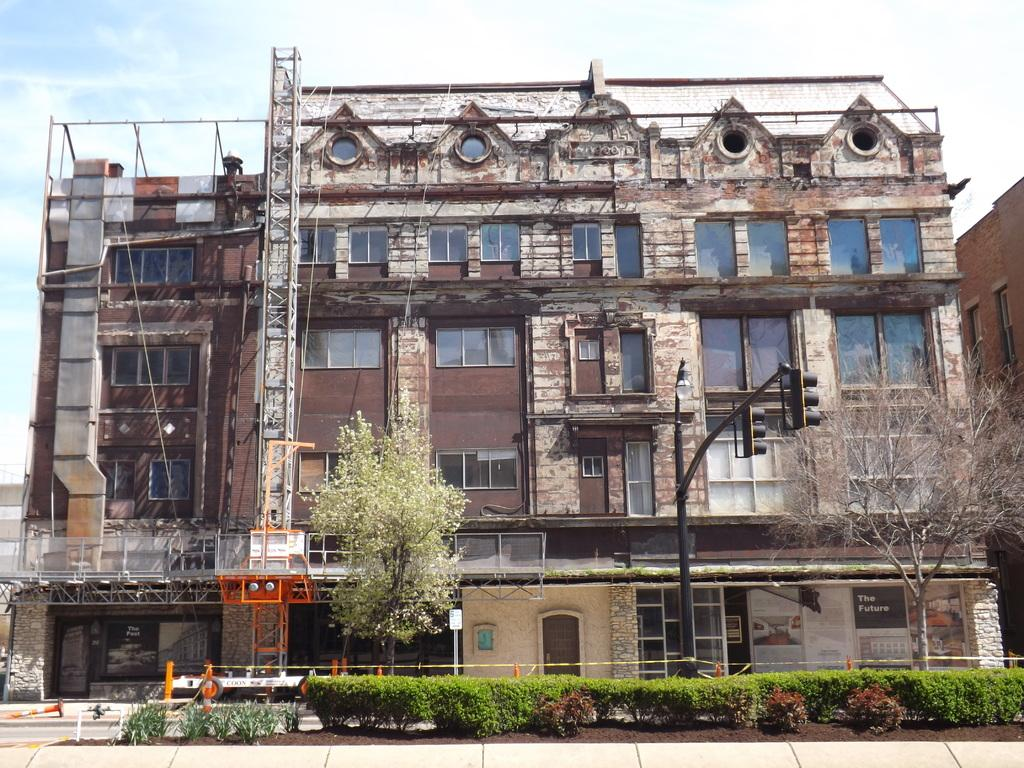What type of vegetation can be seen in the image? There are shrubs and trees in the image. What type of man-made structures are present in the image? There are traffic signal poles, boards, and a building in the image. What is the color of the sky in the background of the image? The sky is blue in the background of the image. What else can be seen in the background of the image? There are clouds in the background of the image. Can you tell me where the kitten is hiding in the image? There is no kitten present in the image. What type of print can be seen on the boards in the image? There is no print visible on the boards in the image. 